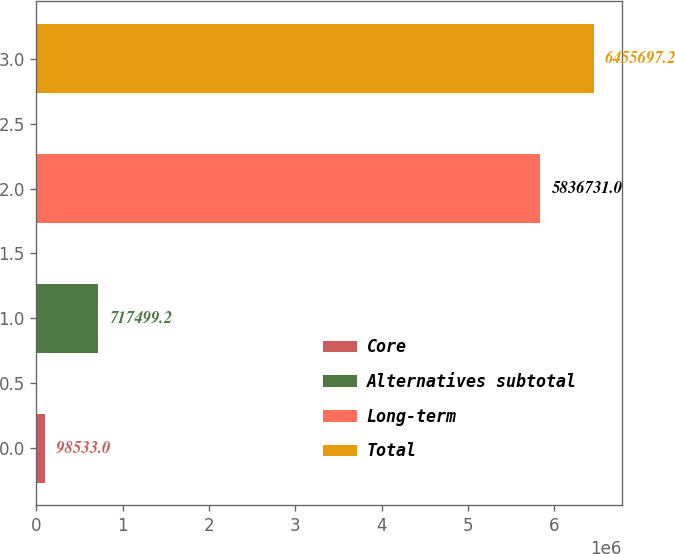Convert chart to OTSL. <chart><loc_0><loc_0><loc_500><loc_500><bar_chart><fcel>Core<fcel>Alternatives subtotal<fcel>Long-term<fcel>Total<nl><fcel>98533<fcel>717499<fcel>5.83673e+06<fcel>6.4557e+06<nl></chart> 